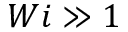Convert formula to latex. <formula><loc_0><loc_0><loc_500><loc_500>W i \gg 1</formula> 